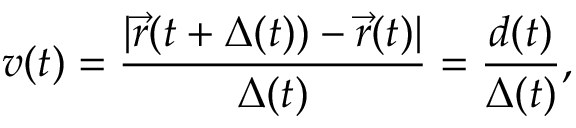<formula> <loc_0><loc_0><loc_500><loc_500>v ( t ) = \frac { | \vec { r } ( t + \Delta ( t ) ) - \vec { r } ( t ) | } { \Delta ( t ) } = \frac { d ( t ) } { \Delta ( t ) } ,</formula> 